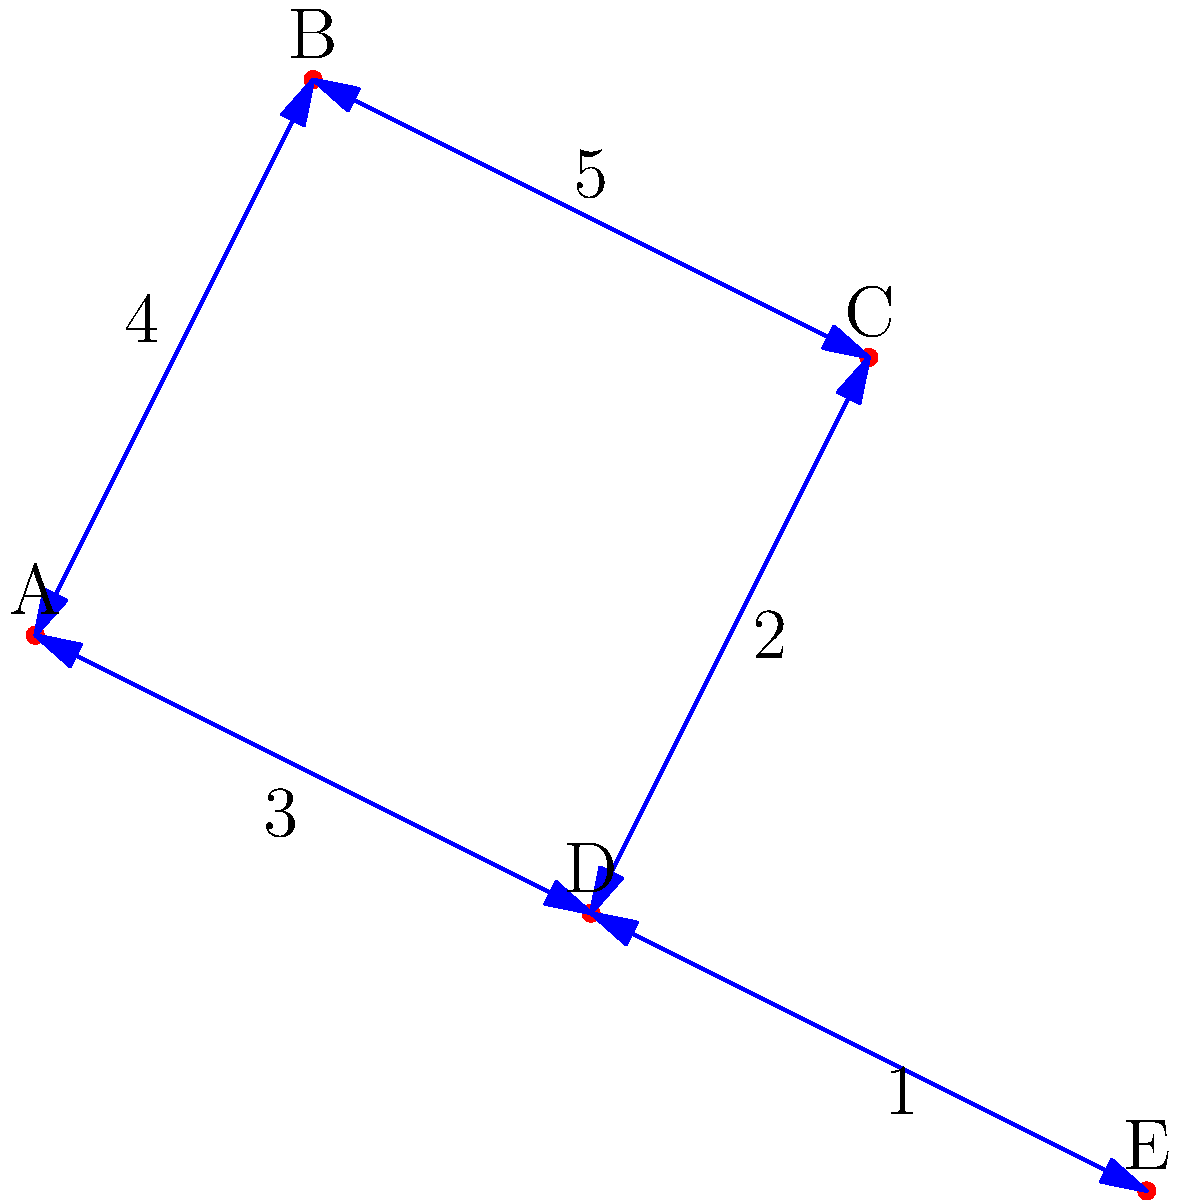As a government official analyzing demographic connections, you're presented with a graph representing different demographic groups (A, B, C, D, E) and the cost of establishing connections between them. What is the total cost of the minimum spanning tree that connects all demographic groups, and which connections should be prioritized to achieve this minimum cost? To find the minimum spanning tree (MST) and its cost, we'll use Kruskal's algorithm:

1. Sort all edges by weight in ascending order:
   E-D (1), C-D (2), A-D (3), A-B (4), B-C (5)

2. Start with an empty MST and add edges that don't create cycles:
   a. Add E-D (cost: 1)
   b. Add C-D (cost: 1 + 2 = 3)
   c. Add A-D (cost: 3 + 3 = 6)
   d. Add A-B (cost: 6 + 4 = 10)

3. The MST is complete as it now includes all vertices.

The minimum spanning tree consists of the edges:
E-D, C-D, A-D, and A-B

The total cost of the MST is $1 + 2 + 3 + 4 = 10$.

This solution minimizes the cost of connecting all demographic groups while ensuring full connectivity. As a government official, prioritizing these connections would lead to the most efficient use of resources in establishing links between different demographic groups.
Answer: Total cost: 10; Prioritized connections: E-D, C-D, A-D, A-B 